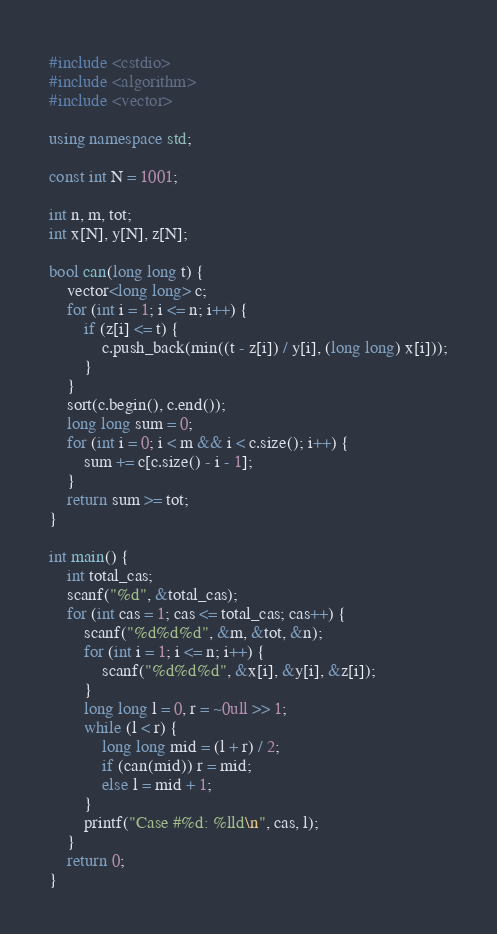<code> <loc_0><loc_0><loc_500><loc_500><_C++_>#include <cstdio>
#include <algorithm>
#include <vector>

using namespace std;

const int N = 1001;

int n, m, tot;
int x[N], y[N], z[N];

bool can(long long t) {
    vector<long long> c;
    for (int i = 1; i <= n; i++) {
        if (z[i] <= t) {
            c.push_back(min((t - z[i]) / y[i], (long long) x[i]));
        }
    }
    sort(c.begin(), c.end());
    long long sum = 0;
    for (int i = 0; i < m && i < c.size(); i++) {
        sum += c[c.size() - i - 1];
    }
    return sum >= tot;
}

int main() {
    int total_cas;
    scanf("%d", &total_cas);
    for (int cas = 1; cas <= total_cas; cas++) {
        scanf("%d%d%d", &m, &tot, &n);
        for (int i = 1; i <= n; i++) {
            scanf("%d%d%d", &x[i], &y[i], &z[i]);
        }
        long long l = 0, r = ~0ull >> 1;
        while (l < r) {
            long long mid = (l + r) / 2;
            if (can(mid)) r = mid;
            else l = mid + 1;
        }
        printf("Case #%d: %lld\n", cas, l);
    }
    return 0;
}
</code> 